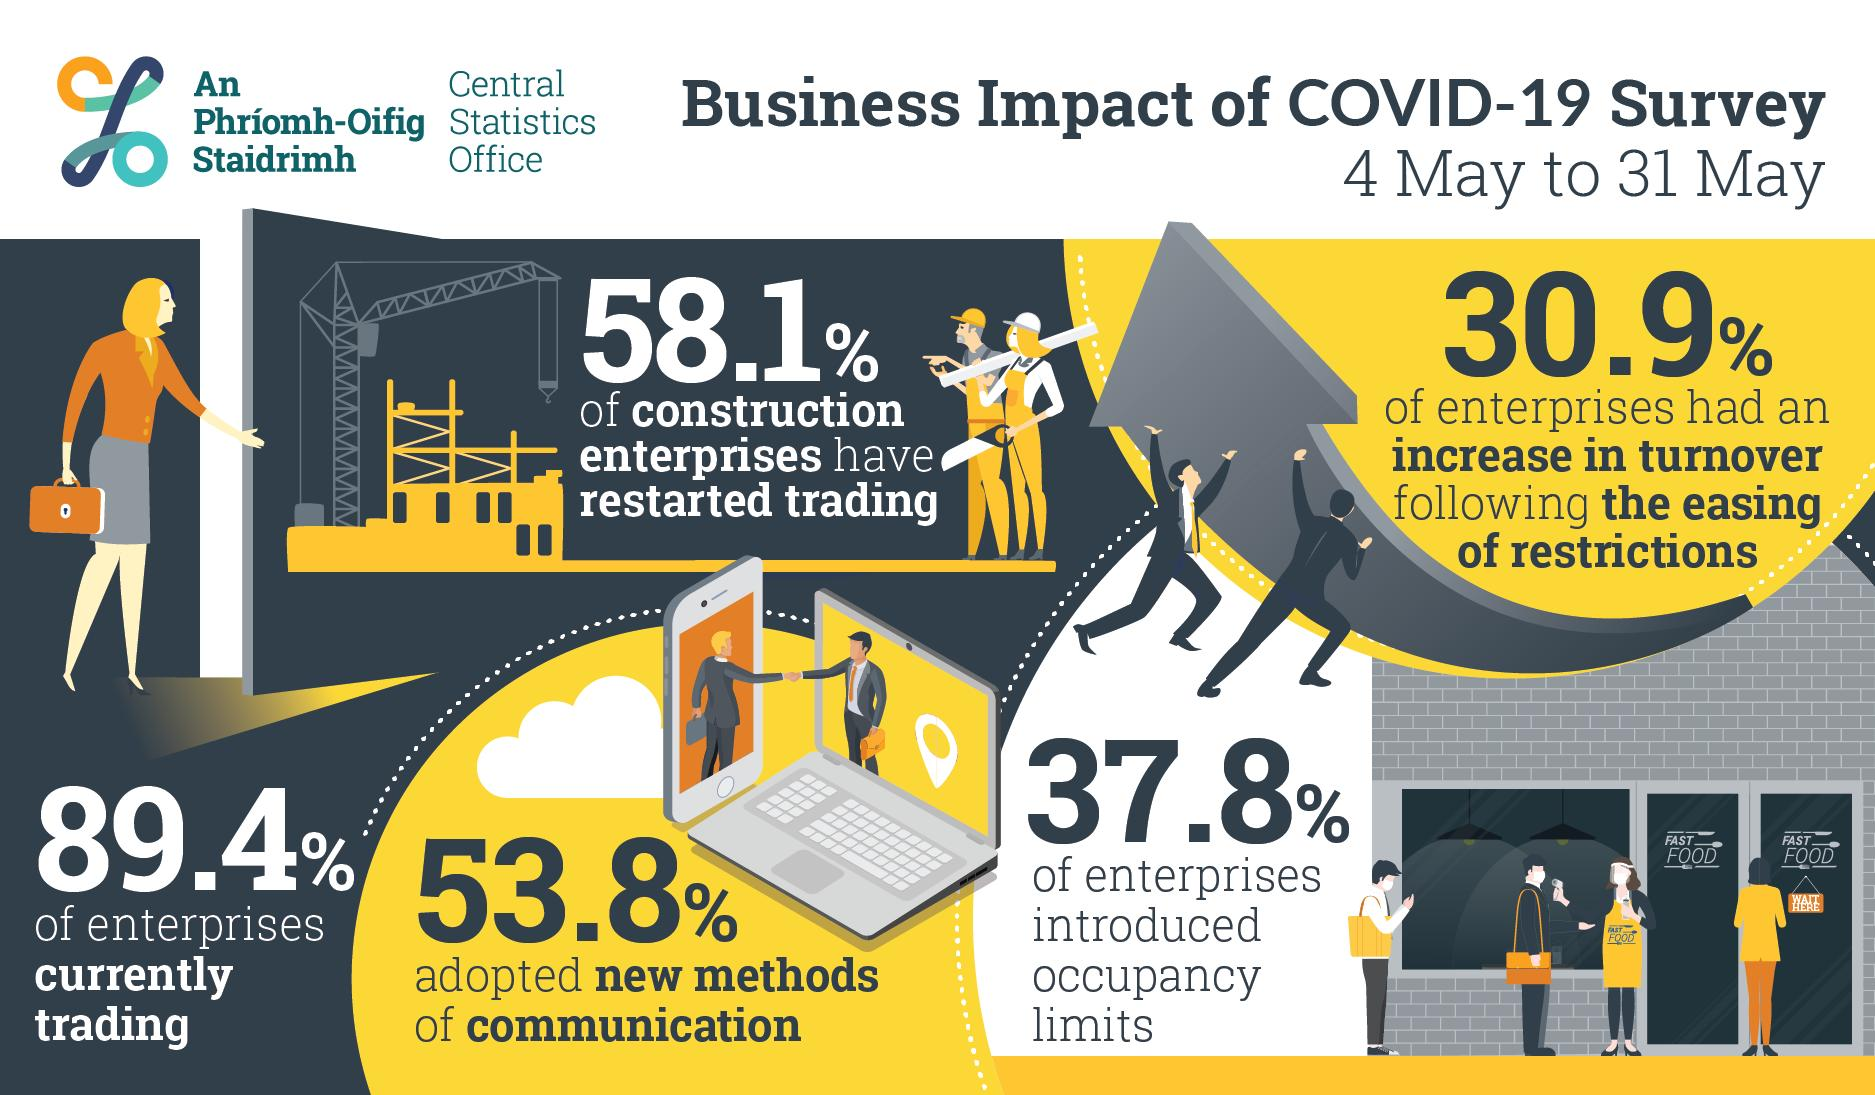Point out several critical features in this image. According to the data, a majority of construction enterprises, 58.1%, have restarted trading following the disaster. The apron worn by the lady bears the inscription "Fast Food," indicating its purpose as a garment used in the preparation and service of quick meals. A total of 53.8% of individuals adopted new methods of communication. Thirty-seven point eight percent of enterprises introduced occupancy limits. The sign board hanging on the door has writing on it that reads 'Wait here.' 